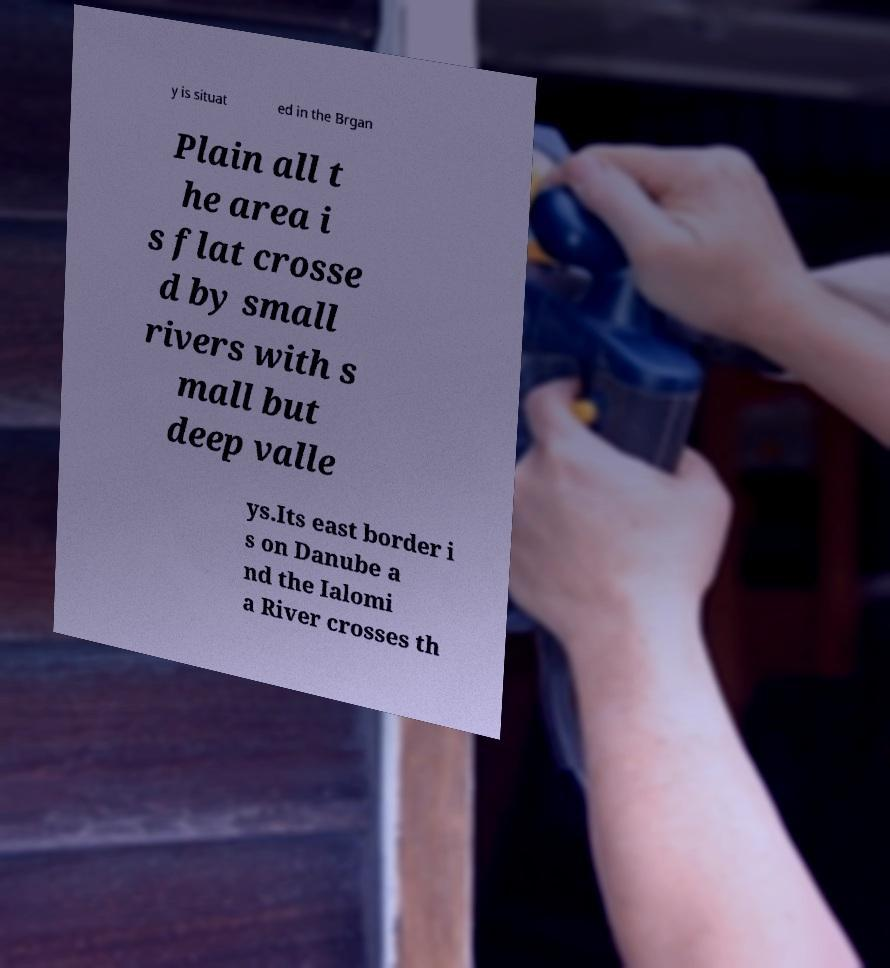There's text embedded in this image that I need extracted. Can you transcribe it verbatim? y is situat ed in the Brgan Plain all t he area i s flat crosse d by small rivers with s mall but deep valle ys.Its east border i s on Danube a nd the Ialomi a River crosses th 